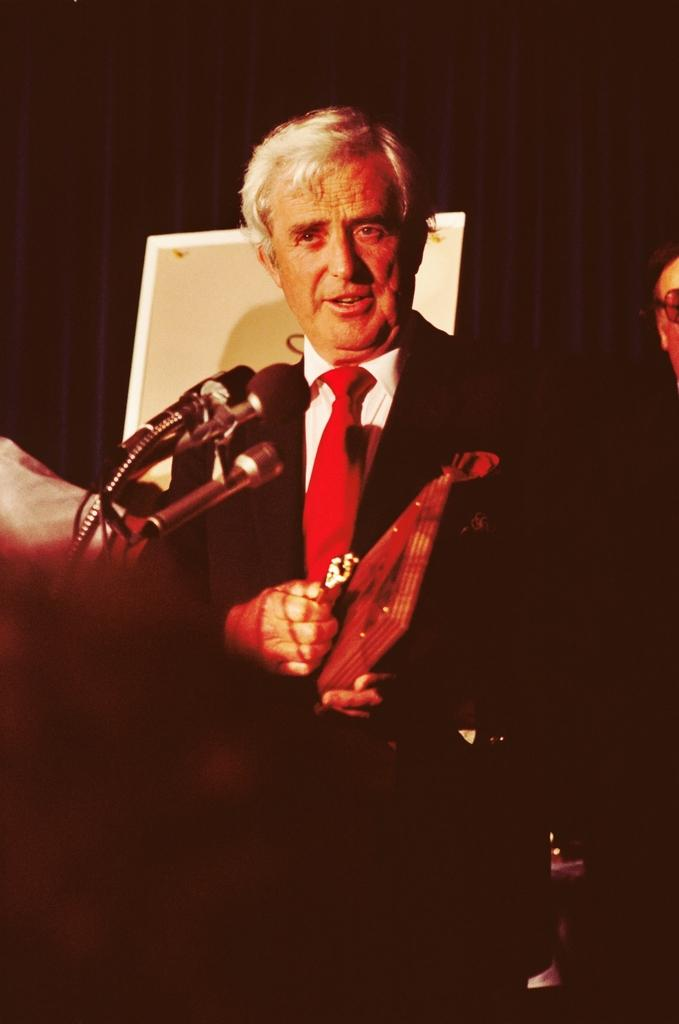What is the main subject of the image? There is a person visible in front of a microphone. Can you describe the background of the image? The background of the image is dark. Are there any other people visible in the image? There might be another person on the right side of the image. What type of toothpaste is the person using while standing in front of the microphone? There is no toothpaste present in the image, and the person is not using any toothpaste while standing in front of the microphone. 